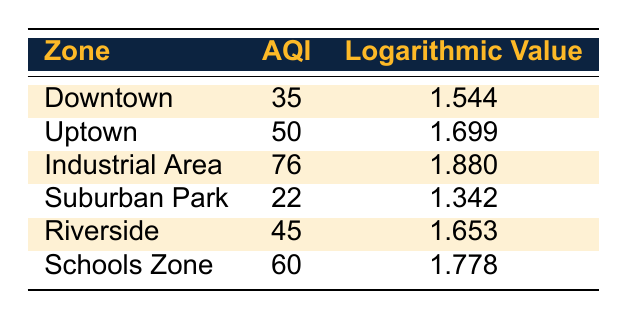What is the Air Quality Index of the Industrial Area? The table shows that the Air Quality Index (AQI) for the Industrial Area is 76. This value is directly listed under the AQI column corresponding to that zone.
Answer: 76 Which zone has the lowest Air Quality Index? Looking through the AQI values for all zones, Suburban Park has the lowest value of 22, making it the zone with the least Air Quality Index.
Answer: Suburban Park What is the average AQI for the Downtown, Uptown, and Riverside zones? To find the average AQI, we first sum the AQI values for these zones: 35 (Downtown) + 50 (Uptown) + 45 (Riverside) = 130. Then, we divide this sum by the number of zones, which is 3. So, 130 / 3 = 43.33.
Answer: 43.33 Is the logarithmic value for the Schools Zone greater than that for the Uptown zone? The logarithmic value for Schools Zone is 1.778, and for Uptown, it is 1.699. Since 1.778 is greater than 1.699, the statement is true.
Answer: Yes Which zones have an AQI greater than 50? We look at the AQI values listed: Industrial Area (76) and Schools Zone (60) both have AQI values greater than 50. Therefore, the zones that qualify are Industrial Area and Schools Zone.
Answer: Industrial Area and Schools Zone What is the difference in AQI between the Industrial Area and Suburban Park? The AQI for the Industrial Area is 76 and for Suburban Park, it is 22. To find the difference, we subtract the lower value from the higher: 76 - 22 = 54.
Answer: 54 Are there any zones with a logarithmic value less than 1.6? Looking at the logarithmic values, Suburban Park (1.342) and Downtown (1.544) both have values less than 1.6. Therefore, the answer is yes.
Answer: Yes What is the total AQI across all zones? To find the total AQI, we sum the AQI for all the zones: 35 (Downtown) + 50 (Uptown) + 76 (Industrial Area) + 22 (Suburban Park) + 45 (Riverside) + 60 (Schools Zone) = 288.
Answer: 288 